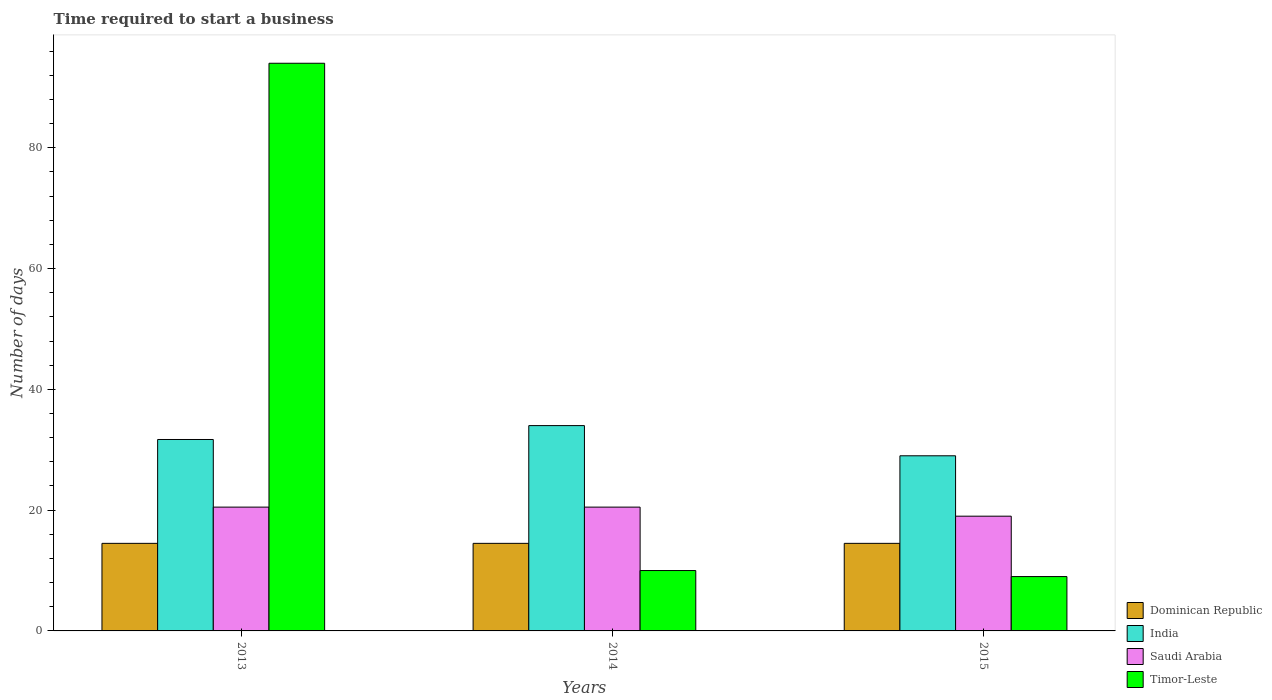How many different coloured bars are there?
Provide a succinct answer. 4. Are the number of bars per tick equal to the number of legend labels?
Provide a short and direct response. Yes. How many bars are there on the 3rd tick from the right?
Your answer should be very brief. 4. What is the label of the 3rd group of bars from the left?
Ensure brevity in your answer.  2015. In how many cases, is the number of bars for a given year not equal to the number of legend labels?
Offer a very short reply. 0. What is the number of days required to start a business in Dominican Republic in 2014?
Make the answer very short. 14.5. Across all years, what is the maximum number of days required to start a business in India?
Make the answer very short. 34. In which year was the number of days required to start a business in Timor-Leste minimum?
Provide a short and direct response. 2015. What is the total number of days required to start a business in India in the graph?
Make the answer very short. 94.7. What is the difference between the number of days required to start a business in India in 2013 and that in 2014?
Your response must be concise. -2.3. What is the difference between the number of days required to start a business in India in 2015 and the number of days required to start a business in Dominican Republic in 2013?
Keep it short and to the point. 14.5. In the year 2015, what is the difference between the number of days required to start a business in Timor-Leste and number of days required to start a business in India?
Offer a terse response. -20. In how many years, is the number of days required to start a business in India greater than 56 days?
Give a very brief answer. 0. Is the difference between the number of days required to start a business in Timor-Leste in 2014 and 2015 greater than the difference between the number of days required to start a business in India in 2014 and 2015?
Offer a very short reply. No. What is the difference between the highest and the second highest number of days required to start a business in India?
Your response must be concise. 2.3. What is the difference between the highest and the lowest number of days required to start a business in Dominican Republic?
Your answer should be very brief. 0. Is the sum of the number of days required to start a business in India in 2013 and 2014 greater than the maximum number of days required to start a business in Timor-Leste across all years?
Provide a succinct answer. No. What does the 4th bar from the left in 2013 represents?
Your answer should be compact. Timor-Leste. What does the 4th bar from the right in 2014 represents?
Offer a very short reply. Dominican Republic. Are all the bars in the graph horizontal?
Provide a short and direct response. No. How many years are there in the graph?
Offer a very short reply. 3. Does the graph contain grids?
Offer a very short reply. No. Where does the legend appear in the graph?
Offer a terse response. Bottom right. What is the title of the graph?
Ensure brevity in your answer.  Time required to start a business. What is the label or title of the Y-axis?
Provide a short and direct response. Number of days. What is the Number of days of India in 2013?
Offer a very short reply. 31.7. What is the Number of days in Saudi Arabia in 2013?
Make the answer very short. 20.5. What is the Number of days of Timor-Leste in 2013?
Offer a terse response. 94. What is the Number of days of Timor-Leste in 2014?
Provide a succinct answer. 10. What is the Number of days in India in 2015?
Provide a short and direct response. 29. What is the Number of days in Saudi Arabia in 2015?
Provide a succinct answer. 19. What is the Number of days of Timor-Leste in 2015?
Ensure brevity in your answer.  9. Across all years, what is the maximum Number of days in Dominican Republic?
Provide a short and direct response. 14.5. Across all years, what is the maximum Number of days of Saudi Arabia?
Your response must be concise. 20.5. Across all years, what is the maximum Number of days of Timor-Leste?
Keep it short and to the point. 94. Across all years, what is the minimum Number of days in India?
Your answer should be compact. 29. Across all years, what is the minimum Number of days in Saudi Arabia?
Offer a terse response. 19. Across all years, what is the minimum Number of days of Timor-Leste?
Your answer should be compact. 9. What is the total Number of days in Dominican Republic in the graph?
Your answer should be very brief. 43.5. What is the total Number of days in India in the graph?
Offer a terse response. 94.7. What is the total Number of days in Saudi Arabia in the graph?
Give a very brief answer. 60. What is the total Number of days in Timor-Leste in the graph?
Provide a short and direct response. 113. What is the difference between the Number of days of Dominican Republic in 2013 and that in 2014?
Your answer should be compact. 0. What is the difference between the Number of days of Dominican Republic in 2013 and that in 2015?
Provide a short and direct response. 0. What is the difference between the Number of days of Saudi Arabia in 2013 and that in 2015?
Your answer should be very brief. 1.5. What is the difference between the Number of days in Timor-Leste in 2013 and that in 2015?
Provide a short and direct response. 85. What is the difference between the Number of days of Dominican Republic in 2014 and that in 2015?
Offer a very short reply. 0. What is the difference between the Number of days of India in 2014 and that in 2015?
Offer a terse response. 5. What is the difference between the Number of days of Saudi Arabia in 2014 and that in 2015?
Your answer should be very brief. 1.5. What is the difference between the Number of days of Timor-Leste in 2014 and that in 2015?
Your answer should be very brief. 1. What is the difference between the Number of days in Dominican Republic in 2013 and the Number of days in India in 2014?
Offer a very short reply. -19.5. What is the difference between the Number of days in India in 2013 and the Number of days in Saudi Arabia in 2014?
Your answer should be very brief. 11.2. What is the difference between the Number of days of India in 2013 and the Number of days of Timor-Leste in 2014?
Your answer should be very brief. 21.7. What is the difference between the Number of days in Saudi Arabia in 2013 and the Number of days in Timor-Leste in 2014?
Ensure brevity in your answer.  10.5. What is the difference between the Number of days in Dominican Republic in 2013 and the Number of days in Saudi Arabia in 2015?
Provide a short and direct response. -4.5. What is the difference between the Number of days in India in 2013 and the Number of days in Saudi Arabia in 2015?
Offer a terse response. 12.7. What is the difference between the Number of days in India in 2013 and the Number of days in Timor-Leste in 2015?
Offer a very short reply. 22.7. What is the difference between the Number of days in Dominican Republic in 2014 and the Number of days in Saudi Arabia in 2015?
Your answer should be compact. -4.5. What is the difference between the Number of days in Dominican Republic in 2014 and the Number of days in Timor-Leste in 2015?
Ensure brevity in your answer.  5.5. What is the difference between the Number of days in India in 2014 and the Number of days in Saudi Arabia in 2015?
Offer a terse response. 15. What is the difference between the Number of days in Saudi Arabia in 2014 and the Number of days in Timor-Leste in 2015?
Ensure brevity in your answer.  11.5. What is the average Number of days in Dominican Republic per year?
Keep it short and to the point. 14.5. What is the average Number of days of India per year?
Give a very brief answer. 31.57. What is the average Number of days in Saudi Arabia per year?
Provide a short and direct response. 20. What is the average Number of days in Timor-Leste per year?
Your answer should be compact. 37.67. In the year 2013, what is the difference between the Number of days of Dominican Republic and Number of days of India?
Give a very brief answer. -17.2. In the year 2013, what is the difference between the Number of days of Dominican Republic and Number of days of Timor-Leste?
Provide a succinct answer. -79.5. In the year 2013, what is the difference between the Number of days of India and Number of days of Saudi Arabia?
Give a very brief answer. 11.2. In the year 2013, what is the difference between the Number of days in India and Number of days in Timor-Leste?
Make the answer very short. -62.3. In the year 2013, what is the difference between the Number of days of Saudi Arabia and Number of days of Timor-Leste?
Your answer should be compact. -73.5. In the year 2014, what is the difference between the Number of days in Dominican Republic and Number of days in India?
Ensure brevity in your answer.  -19.5. In the year 2014, what is the difference between the Number of days in India and Number of days in Saudi Arabia?
Ensure brevity in your answer.  13.5. In the year 2014, what is the difference between the Number of days in India and Number of days in Timor-Leste?
Your answer should be compact. 24. In the year 2014, what is the difference between the Number of days in Saudi Arabia and Number of days in Timor-Leste?
Keep it short and to the point. 10.5. In the year 2015, what is the difference between the Number of days of Dominican Republic and Number of days of Saudi Arabia?
Keep it short and to the point. -4.5. In the year 2015, what is the difference between the Number of days in Dominican Republic and Number of days in Timor-Leste?
Offer a very short reply. 5.5. In the year 2015, what is the difference between the Number of days in India and Number of days in Saudi Arabia?
Provide a short and direct response. 10. In the year 2015, what is the difference between the Number of days of India and Number of days of Timor-Leste?
Keep it short and to the point. 20. In the year 2015, what is the difference between the Number of days in Saudi Arabia and Number of days in Timor-Leste?
Offer a terse response. 10. What is the ratio of the Number of days in Dominican Republic in 2013 to that in 2014?
Offer a terse response. 1. What is the ratio of the Number of days of India in 2013 to that in 2014?
Your answer should be very brief. 0.93. What is the ratio of the Number of days of Saudi Arabia in 2013 to that in 2014?
Your answer should be compact. 1. What is the ratio of the Number of days in India in 2013 to that in 2015?
Keep it short and to the point. 1.09. What is the ratio of the Number of days of Saudi Arabia in 2013 to that in 2015?
Your answer should be very brief. 1.08. What is the ratio of the Number of days in Timor-Leste in 2013 to that in 2015?
Make the answer very short. 10.44. What is the ratio of the Number of days of India in 2014 to that in 2015?
Give a very brief answer. 1.17. What is the ratio of the Number of days in Saudi Arabia in 2014 to that in 2015?
Keep it short and to the point. 1.08. What is the difference between the highest and the second highest Number of days of Saudi Arabia?
Keep it short and to the point. 0. What is the difference between the highest and the second highest Number of days of Timor-Leste?
Offer a very short reply. 84. What is the difference between the highest and the lowest Number of days in Dominican Republic?
Offer a terse response. 0. What is the difference between the highest and the lowest Number of days of India?
Make the answer very short. 5. What is the difference between the highest and the lowest Number of days of Saudi Arabia?
Your answer should be compact. 1.5. 